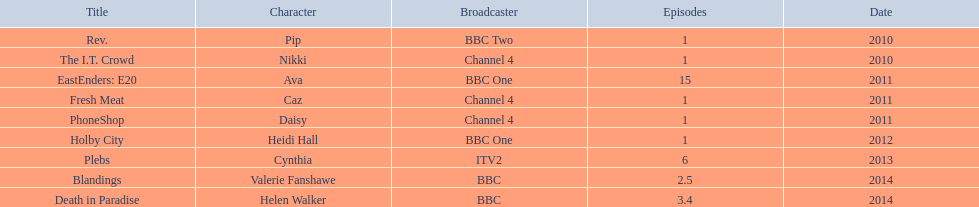What characters did she portray? Pip, Nikki, Ava, Caz, Daisy, Heidi Hall, Cynthia, Valerie Fanshawe, Helen Walker. Parse the table in full. {'header': ['Title', 'Character', 'Broadcaster', 'Episodes', 'Date'], 'rows': [['Rev.', 'Pip', 'BBC Two', '1', '2010'], ['The I.T. Crowd', 'Nikki', 'Channel 4', '1', '2010'], ['EastEnders: E20', 'Ava', 'BBC One', '15', '2011'], ['Fresh Meat', 'Caz', 'Channel 4', '1', '2011'], ['PhoneShop', 'Daisy', 'Channel 4', '1', '2011'], ['Holby City', 'Heidi Hall', 'BBC One', '1', '2012'], ['Plebs', 'Cynthia', 'ITV2', '6', '2013'], ['Blandings', 'Valerie Fanshawe', 'BBC', '2.5', '2014'], ['Death in Paradise', 'Helen Walker', 'BBC', '3.4', '2014']]} On which networks? BBC Two, Channel 4, BBC One, Channel 4, Channel 4, BBC One, ITV2, BBC, BBC. Which characters did she enact for itv2? Cynthia. 